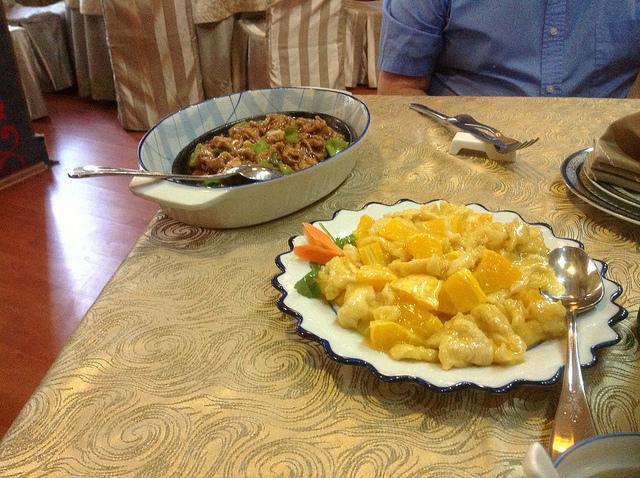How many prongs are on the fork?
Give a very brief answer. 4. How many spoons are there?
Give a very brief answer. 1. 